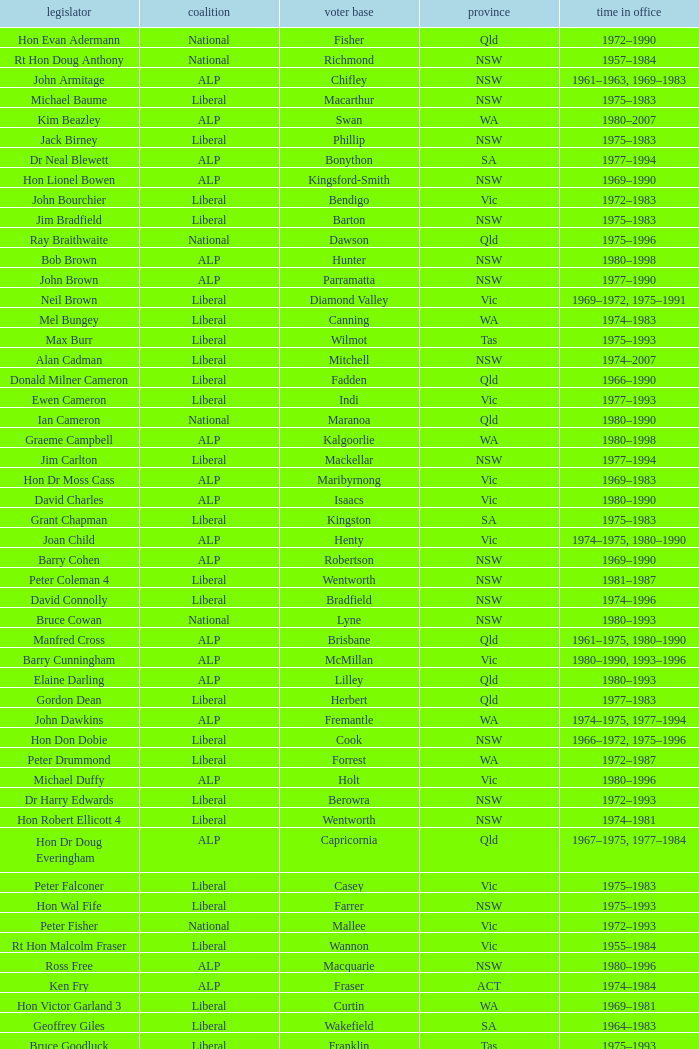To what party does Ralph Jacobi belong? ALP. 